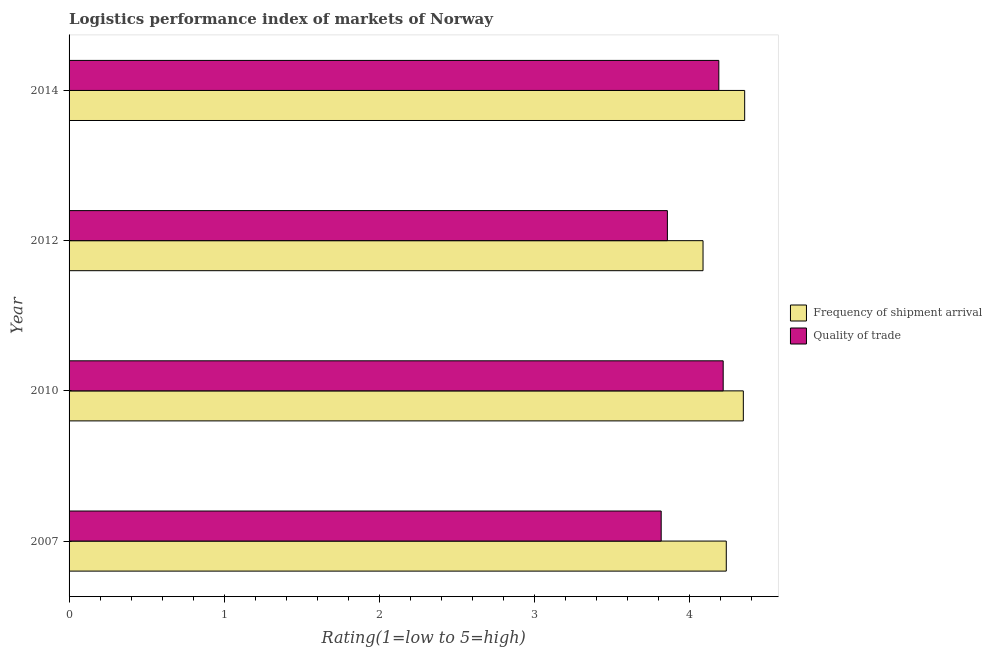Are the number of bars per tick equal to the number of legend labels?
Make the answer very short. Yes. Are the number of bars on each tick of the Y-axis equal?
Your answer should be compact. Yes. How many bars are there on the 3rd tick from the bottom?
Provide a short and direct response. 2. In how many cases, is the number of bars for a given year not equal to the number of legend labels?
Your answer should be very brief. 0. What is the lpi quality of trade in 2010?
Provide a succinct answer. 4.22. Across all years, what is the maximum lpi of frequency of shipment arrival?
Your answer should be very brief. 4.36. Across all years, what is the minimum lpi quality of trade?
Provide a succinct answer. 3.82. In which year was the lpi of frequency of shipment arrival maximum?
Your response must be concise. 2014. In which year was the lpi quality of trade minimum?
Keep it short and to the point. 2007. What is the total lpi quality of trade in the graph?
Offer a very short reply. 16.09. What is the difference between the lpi quality of trade in 2012 and that in 2014?
Offer a very short reply. -0.33. What is the difference between the lpi of frequency of shipment arrival in 2012 and the lpi quality of trade in 2007?
Give a very brief answer. 0.27. What is the average lpi of frequency of shipment arrival per year?
Keep it short and to the point. 4.26. In the year 2012, what is the difference between the lpi quality of trade and lpi of frequency of shipment arrival?
Your response must be concise. -0.23. What is the ratio of the lpi quality of trade in 2007 to that in 2014?
Make the answer very short. 0.91. Is the difference between the lpi of frequency of shipment arrival in 2010 and 2012 greater than the difference between the lpi quality of trade in 2010 and 2012?
Give a very brief answer. No. What is the difference between the highest and the second highest lpi quality of trade?
Make the answer very short. 0.03. What is the difference between the highest and the lowest lpi quality of trade?
Provide a short and direct response. 0.4. In how many years, is the lpi quality of trade greater than the average lpi quality of trade taken over all years?
Your answer should be compact. 2. Is the sum of the lpi quality of trade in 2012 and 2014 greater than the maximum lpi of frequency of shipment arrival across all years?
Keep it short and to the point. Yes. What does the 2nd bar from the top in 2014 represents?
Provide a succinct answer. Frequency of shipment arrival. What does the 1st bar from the bottom in 2007 represents?
Provide a short and direct response. Frequency of shipment arrival. How many bars are there?
Keep it short and to the point. 8. Are all the bars in the graph horizontal?
Ensure brevity in your answer.  Yes. What is the difference between two consecutive major ticks on the X-axis?
Give a very brief answer. 1. Are the values on the major ticks of X-axis written in scientific E-notation?
Give a very brief answer. No. Does the graph contain any zero values?
Provide a succinct answer. No. Where does the legend appear in the graph?
Provide a succinct answer. Center right. How many legend labels are there?
Provide a short and direct response. 2. What is the title of the graph?
Provide a short and direct response. Logistics performance index of markets of Norway. Does "Malaria" appear as one of the legend labels in the graph?
Keep it short and to the point. No. What is the label or title of the X-axis?
Keep it short and to the point. Rating(1=low to 5=high). What is the label or title of the Y-axis?
Offer a terse response. Year. What is the Rating(1=low to 5=high) in Frequency of shipment arrival in 2007?
Provide a short and direct response. 4.24. What is the Rating(1=low to 5=high) in Quality of trade in 2007?
Provide a short and direct response. 3.82. What is the Rating(1=low to 5=high) in Frequency of shipment arrival in 2010?
Ensure brevity in your answer.  4.35. What is the Rating(1=low to 5=high) of Quality of trade in 2010?
Make the answer very short. 4.22. What is the Rating(1=low to 5=high) in Frequency of shipment arrival in 2012?
Make the answer very short. 4.09. What is the Rating(1=low to 5=high) of Quality of trade in 2012?
Give a very brief answer. 3.86. What is the Rating(1=low to 5=high) of Frequency of shipment arrival in 2014?
Provide a succinct answer. 4.36. What is the Rating(1=low to 5=high) of Quality of trade in 2014?
Provide a succinct answer. 4.19. Across all years, what is the maximum Rating(1=low to 5=high) in Frequency of shipment arrival?
Ensure brevity in your answer.  4.36. Across all years, what is the maximum Rating(1=low to 5=high) of Quality of trade?
Provide a succinct answer. 4.22. Across all years, what is the minimum Rating(1=low to 5=high) in Frequency of shipment arrival?
Your response must be concise. 4.09. Across all years, what is the minimum Rating(1=low to 5=high) of Quality of trade?
Provide a succinct answer. 3.82. What is the total Rating(1=low to 5=high) in Frequency of shipment arrival in the graph?
Make the answer very short. 17.04. What is the total Rating(1=low to 5=high) of Quality of trade in the graph?
Offer a very short reply. 16.09. What is the difference between the Rating(1=low to 5=high) in Frequency of shipment arrival in 2007 and that in 2010?
Your answer should be compact. -0.11. What is the difference between the Rating(1=low to 5=high) of Frequency of shipment arrival in 2007 and that in 2012?
Provide a short and direct response. 0.15. What is the difference between the Rating(1=low to 5=high) in Quality of trade in 2007 and that in 2012?
Provide a succinct answer. -0.04. What is the difference between the Rating(1=low to 5=high) of Frequency of shipment arrival in 2007 and that in 2014?
Provide a short and direct response. -0.12. What is the difference between the Rating(1=low to 5=high) in Quality of trade in 2007 and that in 2014?
Ensure brevity in your answer.  -0.37. What is the difference between the Rating(1=low to 5=high) of Frequency of shipment arrival in 2010 and that in 2012?
Give a very brief answer. 0.26. What is the difference between the Rating(1=low to 5=high) of Quality of trade in 2010 and that in 2012?
Ensure brevity in your answer.  0.36. What is the difference between the Rating(1=low to 5=high) in Frequency of shipment arrival in 2010 and that in 2014?
Your answer should be very brief. -0.01. What is the difference between the Rating(1=low to 5=high) in Quality of trade in 2010 and that in 2014?
Keep it short and to the point. 0.03. What is the difference between the Rating(1=low to 5=high) of Frequency of shipment arrival in 2012 and that in 2014?
Offer a terse response. -0.27. What is the difference between the Rating(1=low to 5=high) of Quality of trade in 2012 and that in 2014?
Offer a terse response. -0.33. What is the difference between the Rating(1=low to 5=high) of Frequency of shipment arrival in 2007 and the Rating(1=low to 5=high) of Quality of trade in 2010?
Your answer should be compact. 0.02. What is the difference between the Rating(1=low to 5=high) of Frequency of shipment arrival in 2007 and the Rating(1=low to 5=high) of Quality of trade in 2012?
Keep it short and to the point. 0.38. What is the difference between the Rating(1=low to 5=high) in Frequency of shipment arrival in 2007 and the Rating(1=low to 5=high) in Quality of trade in 2014?
Provide a short and direct response. 0.05. What is the difference between the Rating(1=low to 5=high) in Frequency of shipment arrival in 2010 and the Rating(1=low to 5=high) in Quality of trade in 2012?
Ensure brevity in your answer.  0.49. What is the difference between the Rating(1=low to 5=high) in Frequency of shipment arrival in 2010 and the Rating(1=low to 5=high) in Quality of trade in 2014?
Make the answer very short. 0.16. What is the difference between the Rating(1=low to 5=high) in Frequency of shipment arrival in 2012 and the Rating(1=low to 5=high) in Quality of trade in 2014?
Offer a very short reply. -0.1. What is the average Rating(1=low to 5=high) of Frequency of shipment arrival per year?
Offer a very short reply. 4.26. What is the average Rating(1=low to 5=high) of Quality of trade per year?
Keep it short and to the point. 4.02. In the year 2007, what is the difference between the Rating(1=low to 5=high) of Frequency of shipment arrival and Rating(1=low to 5=high) of Quality of trade?
Your response must be concise. 0.42. In the year 2010, what is the difference between the Rating(1=low to 5=high) of Frequency of shipment arrival and Rating(1=low to 5=high) of Quality of trade?
Provide a succinct answer. 0.13. In the year 2012, what is the difference between the Rating(1=low to 5=high) of Frequency of shipment arrival and Rating(1=low to 5=high) of Quality of trade?
Make the answer very short. 0.23. In the year 2014, what is the difference between the Rating(1=low to 5=high) in Frequency of shipment arrival and Rating(1=low to 5=high) in Quality of trade?
Provide a succinct answer. 0.17. What is the ratio of the Rating(1=low to 5=high) in Frequency of shipment arrival in 2007 to that in 2010?
Provide a succinct answer. 0.97. What is the ratio of the Rating(1=low to 5=high) in Quality of trade in 2007 to that in 2010?
Offer a very short reply. 0.91. What is the ratio of the Rating(1=low to 5=high) of Frequency of shipment arrival in 2007 to that in 2012?
Provide a succinct answer. 1.04. What is the ratio of the Rating(1=low to 5=high) of Frequency of shipment arrival in 2007 to that in 2014?
Give a very brief answer. 0.97. What is the ratio of the Rating(1=low to 5=high) of Quality of trade in 2007 to that in 2014?
Your answer should be compact. 0.91. What is the ratio of the Rating(1=low to 5=high) in Frequency of shipment arrival in 2010 to that in 2012?
Keep it short and to the point. 1.06. What is the ratio of the Rating(1=low to 5=high) of Quality of trade in 2010 to that in 2012?
Provide a succinct answer. 1.09. What is the ratio of the Rating(1=low to 5=high) of Quality of trade in 2010 to that in 2014?
Provide a short and direct response. 1.01. What is the ratio of the Rating(1=low to 5=high) in Frequency of shipment arrival in 2012 to that in 2014?
Offer a terse response. 0.94. What is the ratio of the Rating(1=low to 5=high) of Quality of trade in 2012 to that in 2014?
Keep it short and to the point. 0.92. What is the difference between the highest and the second highest Rating(1=low to 5=high) of Frequency of shipment arrival?
Offer a terse response. 0.01. What is the difference between the highest and the second highest Rating(1=low to 5=high) in Quality of trade?
Give a very brief answer. 0.03. What is the difference between the highest and the lowest Rating(1=low to 5=high) in Frequency of shipment arrival?
Offer a terse response. 0.27. What is the difference between the highest and the lowest Rating(1=low to 5=high) in Quality of trade?
Your answer should be compact. 0.4. 